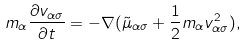Convert formula to latex. <formula><loc_0><loc_0><loc_500><loc_500>m _ { \alpha } \frac { \partial v _ { \alpha \sigma } } { \partial t } = - \nabla ( \tilde { \mu } _ { \alpha \sigma } + \frac { 1 } { 2 } m _ { \alpha } v ^ { 2 } _ { \alpha \sigma } ) ,</formula> 